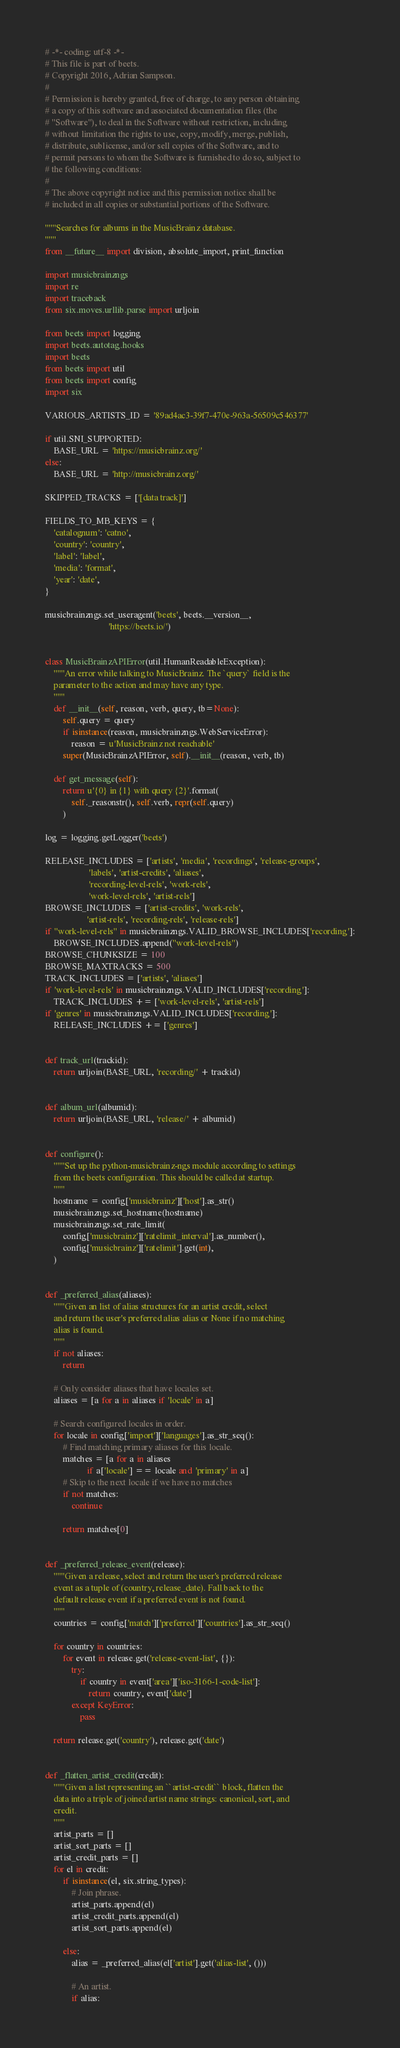Convert code to text. <code><loc_0><loc_0><loc_500><loc_500><_Python_># -*- coding: utf-8 -*-
# This file is part of beets.
# Copyright 2016, Adrian Sampson.
#
# Permission is hereby granted, free of charge, to any person obtaining
# a copy of this software and associated documentation files (the
# "Software"), to deal in the Software without restriction, including
# without limitation the rights to use, copy, modify, merge, publish,
# distribute, sublicense, and/or sell copies of the Software, and to
# permit persons to whom the Software is furnished to do so, subject to
# the following conditions:
#
# The above copyright notice and this permission notice shall be
# included in all copies or substantial portions of the Software.

"""Searches for albums in the MusicBrainz database.
"""
from __future__ import division, absolute_import, print_function

import musicbrainzngs
import re
import traceback
from six.moves.urllib.parse import urljoin

from beets import logging
import beets.autotag.hooks
import beets
from beets import util
from beets import config
import six

VARIOUS_ARTISTS_ID = '89ad4ac3-39f7-470e-963a-56509c546377'

if util.SNI_SUPPORTED:
    BASE_URL = 'https://musicbrainz.org/'
else:
    BASE_URL = 'http://musicbrainz.org/'

SKIPPED_TRACKS = ['[data track]']

FIELDS_TO_MB_KEYS = {
    'catalognum': 'catno',
    'country': 'country',
    'label': 'label',
    'media': 'format',
    'year': 'date',
}

musicbrainzngs.set_useragent('beets', beets.__version__,
                             'https://beets.io/')


class MusicBrainzAPIError(util.HumanReadableException):
    """An error while talking to MusicBrainz. The `query` field is the
    parameter to the action and may have any type.
    """
    def __init__(self, reason, verb, query, tb=None):
        self.query = query
        if isinstance(reason, musicbrainzngs.WebServiceError):
            reason = u'MusicBrainz not reachable'
        super(MusicBrainzAPIError, self).__init__(reason, verb, tb)

    def get_message(self):
        return u'{0} in {1} with query {2}'.format(
            self._reasonstr(), self.verb, repr(self.query)
        )

log = logging.getLogger('beets')

RELEASE_INCLUDES = ['artists', 'media', 'recordings', 'release-groups',
                    'labels', 'artist-credits', 'aliases',
                    'recording-level-rels', 'work-rels',
                    'work-level-rels', 'artist-rels']
BROWSE_INCLUDES = ['artist-credits', 'work-rels',
                   'artist-rels', 'recording-rels', 'release-rels']
if "work-level-rels" in musicbrainzngs.VALID_BROWSE_INCLUDES['recording']:
    BROWSE_INCLUDES.append("work-level-rels")
BROWSE_CHUNKSIZE = 100
BROWSE_MAXTRACKS = 500
TRACK_INCLUDES = ['artists', 'aliases']
if 'work-level-rels' in musicbrainzngs.VALID_INCLUDES['recording']:
    TRACK_INCLUDES += ['work-level-rels', 'artist-rels']
if 'genres' in musicbrainzngs.VALID_INCLUDES['recording']:
    RELEASE_INCLUDES += ['genres']


def track_url(trackid):
    return urljoin(BASE_URL, 'recording/' + trackid)


def album_url(albumid):
    return urljoin(BASE_URL, 'release/' + albumid)


def configure():
    """Set up the python-musicbrainz-ngs module according to settings
    from the beets configuration. This should be called at startup.
    """
    hostname = config['musicbrainz']['host'].as_str()
    musicbrainzngs.set_hostname(hostname)
    musicbrainzngs.set_rate_limit(
        config['musicbrainz']['ratelimit_interval'].as_number(),
        config['musicbrainz']['ratelimit'].get(int),
    )


def _preferred_alias(aliases):
    """Given an list of alias structures for an artist credit, select
    and return the user's preferred alias alias or None if no matching
    alias is found.
    """
    if not aliases:
        return

    # Only consider aliases that have locales set.
    aliases = [a for a in aliases if 'locale' in a]

    # Search configured locales in order.
    for locale in config['import']['languages'].as_str_seq():
        # Find matching primary aliases for this locale.
        matches = [a for a in aliases
                   if a['locale'] == locale and 'primary' in a]
        # Skip to the next locale if we have no matches
        if not matches:
            continue

        return matches[0]


def _preferred_release_event(release):
    """Given a release, select and return the user's preferred release
    event as a tuple of (country, release_date). Fall back to the
    default release event if a preferred event is not found.
    """
    countries = config['match']['preferred']['countries'].as_str_seq()

    for country in countries:
        for event in release.get('release-event-list', {}):
            try:
                if country in event['area']['iso-3166-1-code-list']:
                    return country, event['date']
            except KeyError:
                pass

    return release.get('country'), release.get('date')


def _flatten_artist_credit(credit):
    """Given a list representing an ``artist-credit`` block, flatten the
    data into a triple of joined artist name strings: canonical, sort, and
    credit.
    """
    artist_parts = []
    artist_sort_parts = []
    artist_credit_parts = []
    for el in credit:
        if isinstance(el, six.string_types):
            # Join phrase.
            artist_parts.append(el)
            artist_credit_parts.append(el)
            artist_sort_parts.append(el)

        else:
            alias = _preferred_alias(el['artist'].get('alias-list', ()))

            # An artist.
            if alias:</code> 